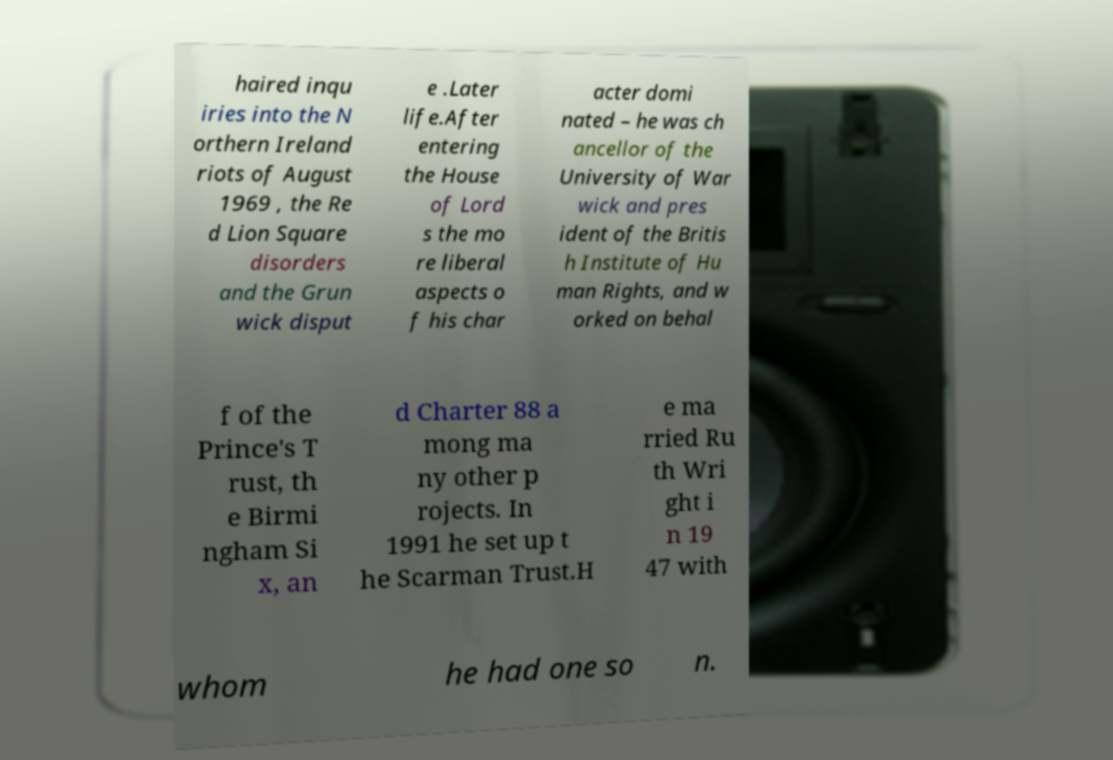There's text embedded in this image that I need extracted. Can you transcribe it verbatim? haired inqu iries into the N orthern Ireland riots of August 1969 , the Re d Lion Square disorders and the Grun wick disput e .Later life.After entering the House of Lord s the mo re liberal aspects o f his char acter domi nated – he was ch ancellor of the University of War wick and pres ident of the Britis h Institute of Hu man Rights, and w orked on behal f of the Prince's T rust, th e Birmi ngham Si x, an d Charter 88 a mong ma ny other p rojects. In 1991 he set up t he Scarman Trust.H e ma rried Ru th Wri ght i n 19 47 with whom he had one so n. 